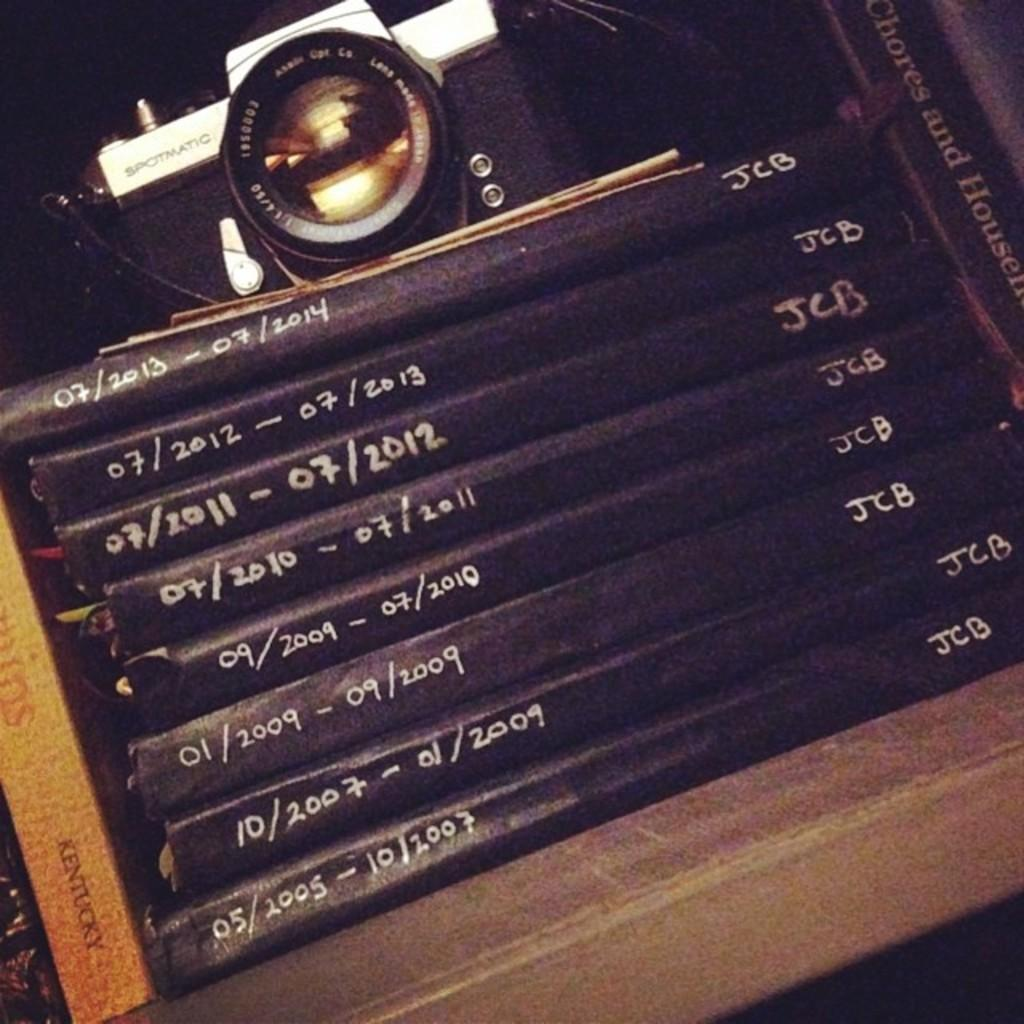<image>
Give a short and clear explanation of the subsequent image. A stack of black albums with the initials JCB listed on each one. 